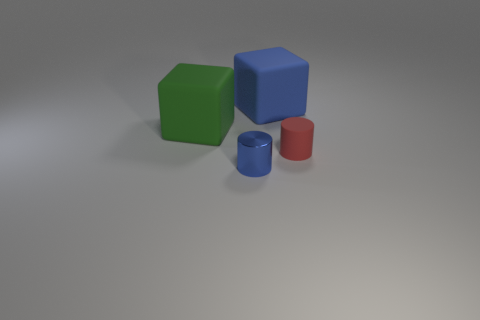Add 2 blue things. How many objects exist? 6 Subtract 1 red cylinders. How many objects are left? 3 Subtract all blue metallic objects. Subtract all tiny red rubber cubes. How many objects are left? 3 Add 1 small blue objects. How many small blue objects are left? 2 Add 2 rubber blocks. How many rubber blocks exist? 4 